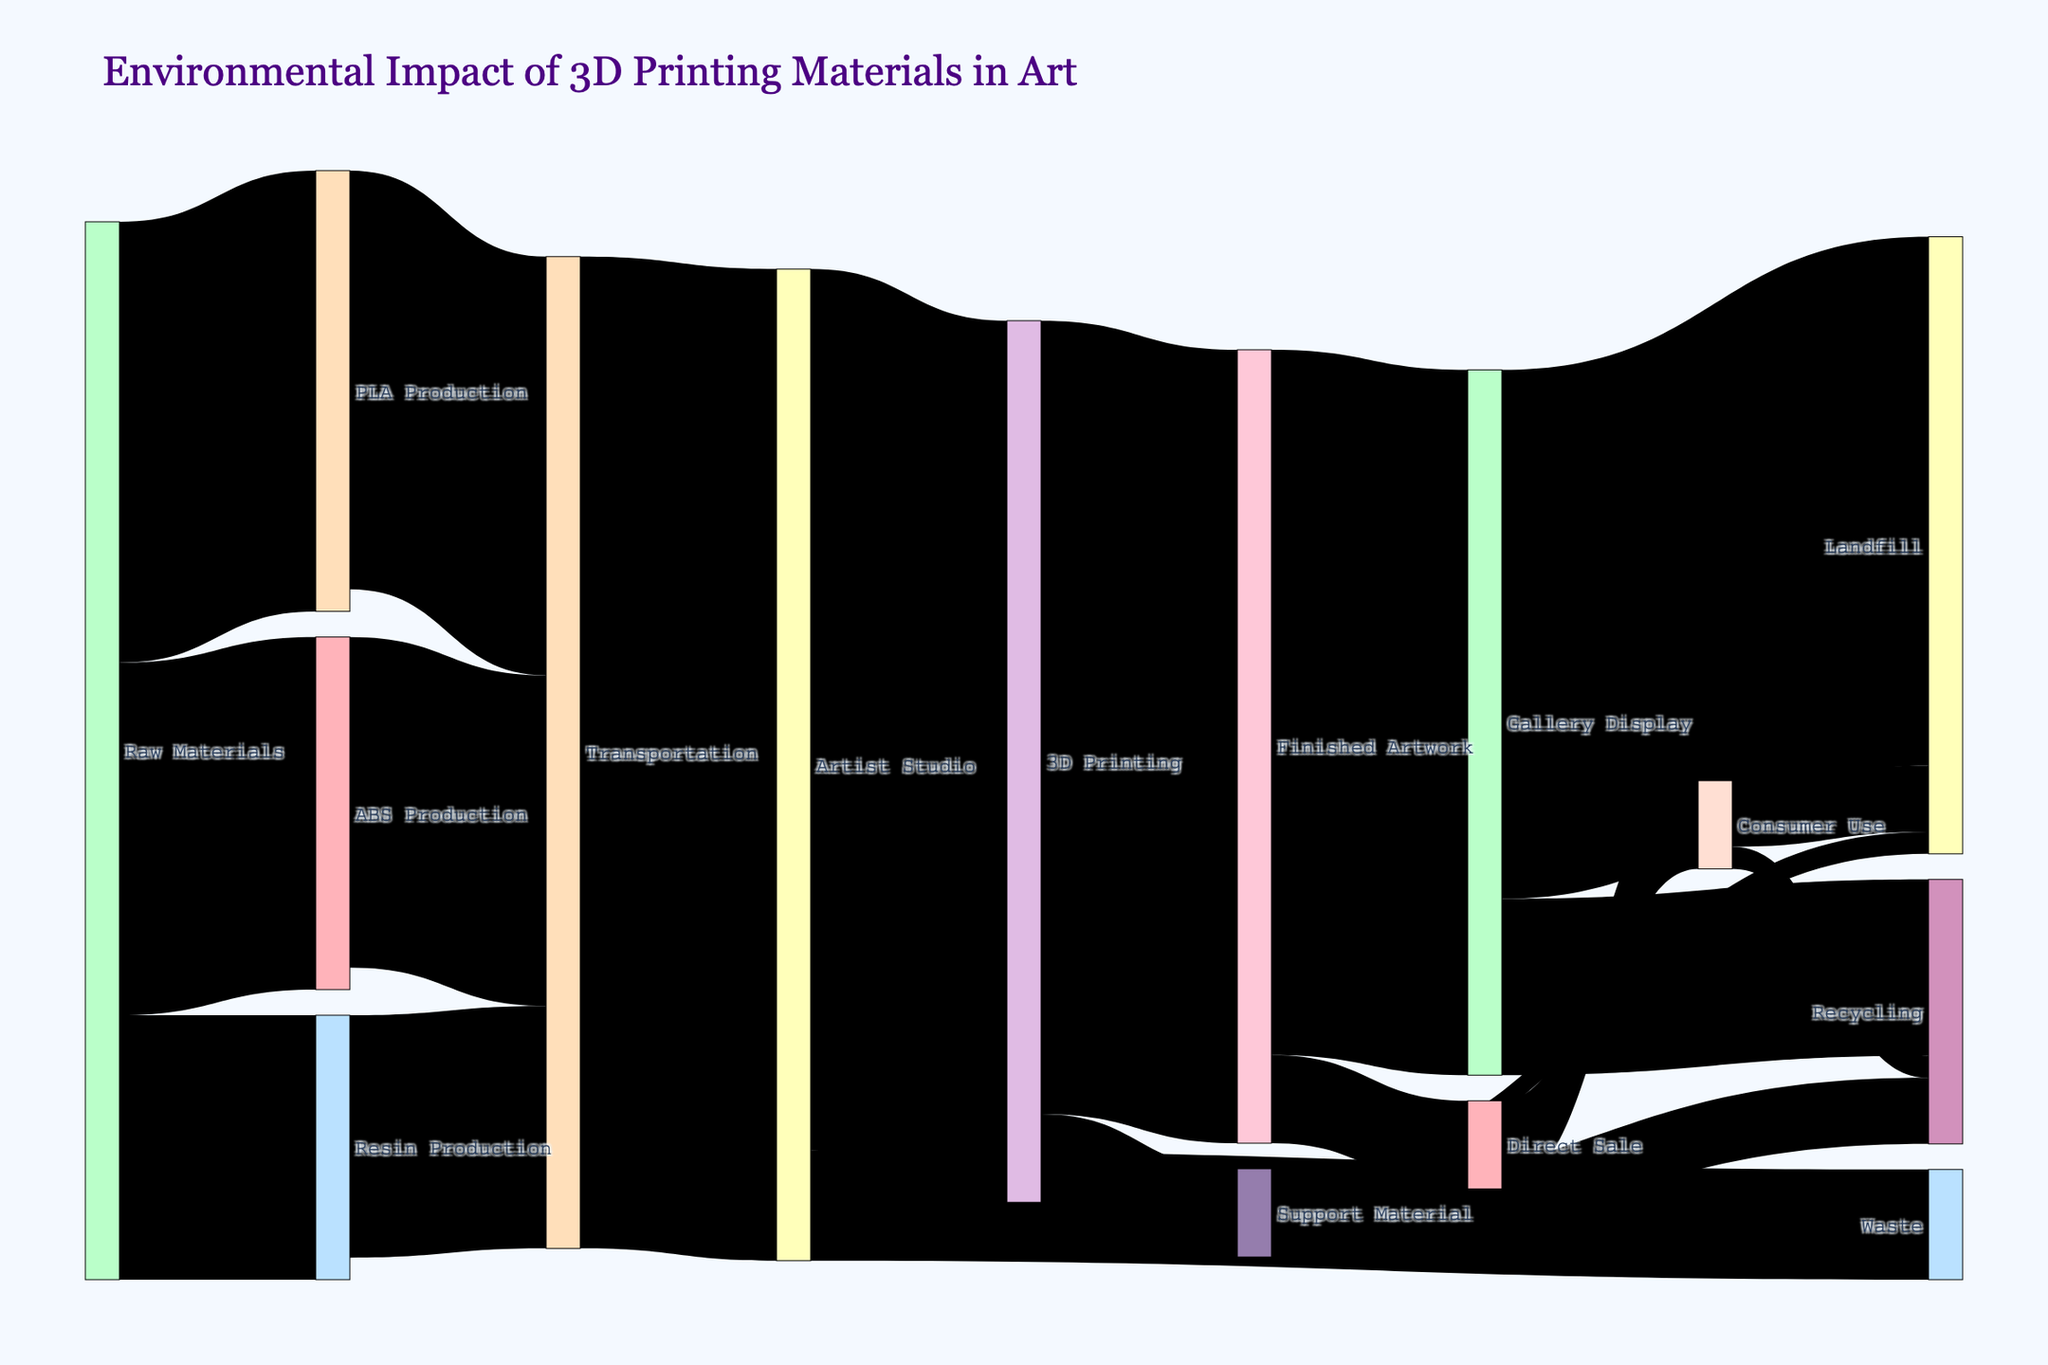What is the title of the Sankey diagram? The title of the Sankey diagram is found at the top of the figure. It reads, "Environmental Impact of 3D Printing Materials in Art".
Answer: Environmental Impact of 3D Printing Materials in Art What is the initial source of all materials in the Sankey diagram? The initial source of all materials is depicted at the far left of the figure under the same label. This initial source is "Raw Materials".
Answer: Raw Materials How many categories are depicted receiving materials directly from the "Artist Studio"? To determine the categories receiving materials, follow the flows starting from "Artist Studio". There are three such categories: "3D Printing", "Waste", and "Transportation".
Answer: 3 Which material has the highest production value and what is it? Trace the flows starting from "Raw Materials" to find the individual production values. "PLA Production" receives the highest value of 100.
Answer: PLA Production with 100 What is the sum of materials going into the "Transportation" node? Identify the flows entering the "Transportation" node and sum their values. The relevant values are from "PLA Production" (95), "ABS Production" (75), and "Resin Production" (55). Adding them gives 95 + 75 + 55.
Answer: 225 What is the combined value of materials that end up in "Landfill" from all sources? Track and sum the flows ending in the "Landfill". These flows are from "Gallery Display" (120), "Support Material" (5), and "Consumer Use" (15). Adding these gives 120 + 5 + 15.
Answer: 140 Compare the quantity of materials going from "Artist Studio" to "3D Printing" and from "Artist Studio" to "Waste". Which is higher and by how much? "Artist Studio" to "3D Printing" has a value of 200, and to "Waste" has a value of 25. The difference is 200 - 25.
Answer: 3D Printing by 175 Does the flow of "Support Material" that is recycled exceed the flow of "Support Material" that ends up in the landfill? Compare the values of "Support Material" that go to "Recycling" (15) with those that go to "Landfill" (5). 15 is greater than 5.
Answer: Yes How much material from "Finished Artwork" is directed to "Gallery Display" and "Direct Sale" respectively? "Finished Artwork" flows to "Gallery Display" with a value of 160 and to "Direct Sale" with a value of 20.
Answer: Gallery Display: 160, Direct Sale: 20 